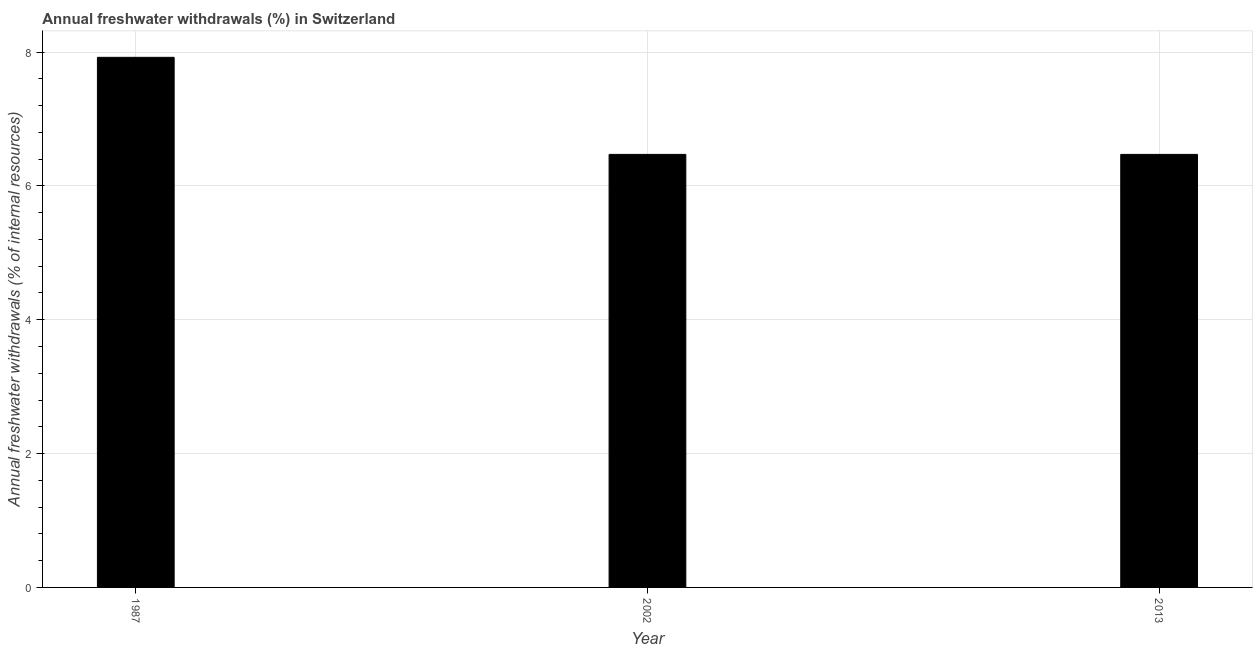Does the graph contain any zero values?
Ensure brevity in your answer.  No. What is the title of the graph?
Ensure brevity in your answer.  Annual freshwater withdrawals (%) in Switzerland. What is the label or title of the X-axis?
Make the answer very short. Year. What is the label or title of the Y-axis?
Provide a short and direct response. Annual freshwater withdrawals (% of internal resources). What is the annual freshwater withdrawals in 1987?
Offer a terse response. 7.92. Across all years, what is the maximum annual freshwater withdrawals?
Your answer should be very brief. 7.92. Across all years, what is the minimum annual freshwater withdrawals?
Offer a very short reply. 6.47. What is the sum of the annual freshwater withdrawals?
Offer a very short reply. 20.86. What is the average annual freshwater withdrawals per year?
Offer a terse response. 6.95. What is the median annual freshwater withdrawals?
Make the answer very short. 6.47. In how many years, is the annual freshwater withdrawals greater than 4 %?
Offer a very short reply. 3. Do a majority of the years between 2002 and 2013 (inclusive) have annual freshwater withdrawals greater than 2.8 %?
Keep it short and to the point. Yes. What is the ratio of the annual freshwater withdrawals in 1987 to that in 2002?
Your answer should be compact. 1.22. Is the annual freshwater withdrawals in 1987 less than that in 2002?
Provide a succinct answer. No. What is the difference between the highest and the second highest annual freshwater withdrawals?
Make the answer very short. 1.45. What is the difference between the highest and the lowest annual freshwater withdrawals?
Keep it short and to the point. 1.45. In how many years, is the annual freshwater withdrawals greater than the average annual freshwater withdrawals taken over all years?
Offer a very short reply. 1. How many bars are there?
Keep it short and to the point. 3. Are all the bars in the graph horizontal?
Offer a terse response. No. What is the difference between two consecutive major ticks on the Y-axis?
Keep it short and to the point. 2. What is the Annual freshwater withdrawals (% of internal resources) of 1987?
Provide a short and direct response. 7.92. What is the Annual freshwater withdrawals (% of internal resources) in 2002?
Offer a terse response. 6.47. What is the Annual freshwater withdrawals (% of internal resources) of 2013?
Your answer should be compact. 6.47. What is the difference between the Annual freshwater withdrawals (% of internal resources) in 1987 and 2002?
Offer a terse response. 1.45. What is the difference between the Annual freshwater withdrawals (% of internal resources) in 1987 and 2013?
Keep it short and to the point. 1.45. What is the difference between the Annual freshwater withdrawals (% of internal resources) in 2002 and 2013?
Provide a succinct answer. 0. What is the ratio of the Annual freshwater withdrawals (% of internal resources) in 1987 to that in 2002?
Your answer should be very brief. 1.22. What is the ratio of the Annual freshwater withdrawals (% of internal resources) in 1987 to that in 2013?
Your answer should be very brief. 1.22. 